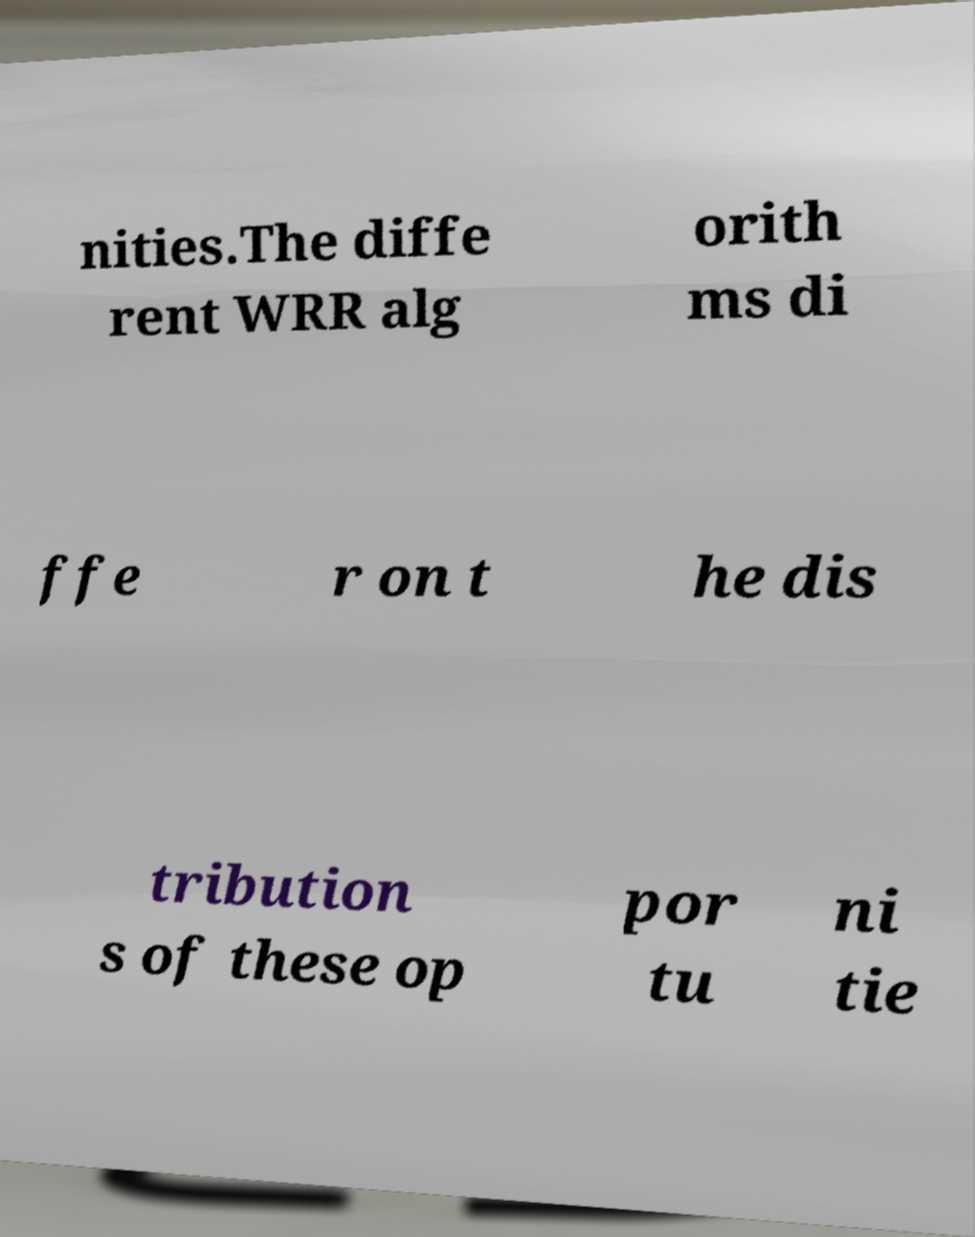Can you read and provide the text displayed in the image?This photo seems to have some interesting text. Can you extract and type it out for me? nities.The diffe rent WRR alg orith ms di ffe r on t he dis tribution s of these op por tu ni tie 